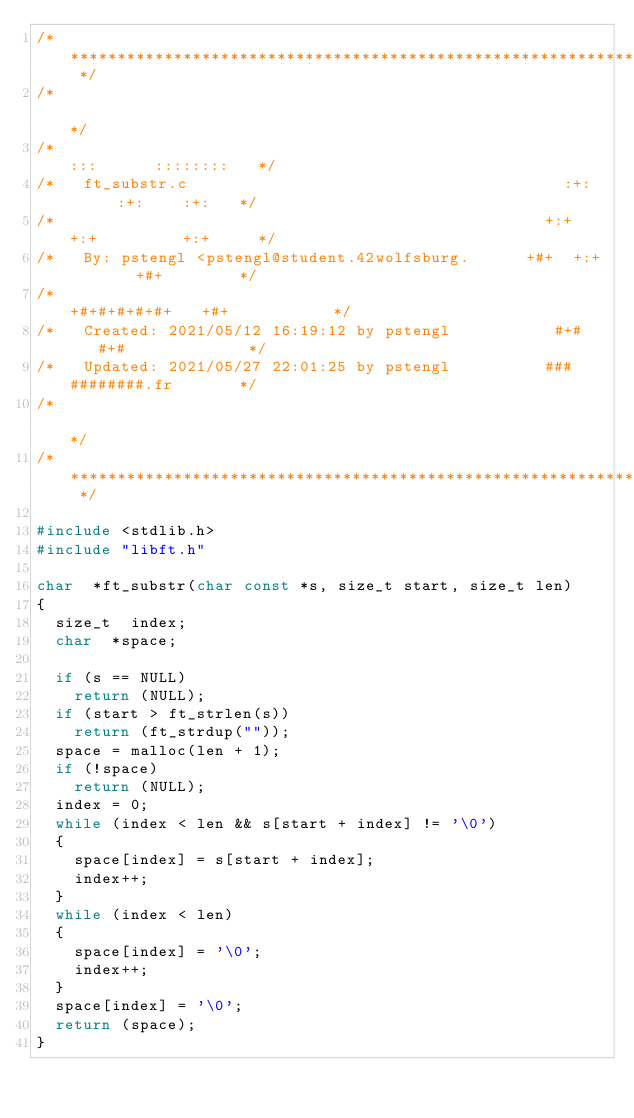Convert code to text. <code><loc_0><loc_0><loc_500><loc_500><_C_>/* ************************************************************************** */
/*                                                                            */
/*                                                        :::      ::::::::   */
/*   ft_substr.c                                        :+:      :+:    :+:   */
/*                                                    +:+ +:+         +:+     */
/*   By: pstengl <pstengl@student.42wolfsburg.      +#+  +:+       +#+        */
/*                                                +#+#+#+#+#+   +#+           */
/*   Created: 2021/05/12 16:19:12 by pstengl           #+#    #+#             */
/*   Updated: 2021/05/27 22:01:25 by pstengl          ###   ########.fr       */
/*                                                                            */
/* ************************************************************************** */

#include <stdlib.h>
#include "libft.h"

char	*ft_substr(char const *s, size_t start, size_t len)
{
	size_t	index;
	char	*space;

	if (s == NULL)
		return (NULL);
	if (start > ft_strlen(s))
		return (ft_strdup(""));
	space = malloc(len + 1);
	if (!space)
		return (NULL);
	index = 0;
	while (index < len && s[start + index] != '\0')
	{
		space[index] = s[start + index];
		index++;
	}
	while (index < len)
	{
		space[index] = '\0';
		index++;
	}
	space[index] = '\0';
	return (space);
}
</code> 